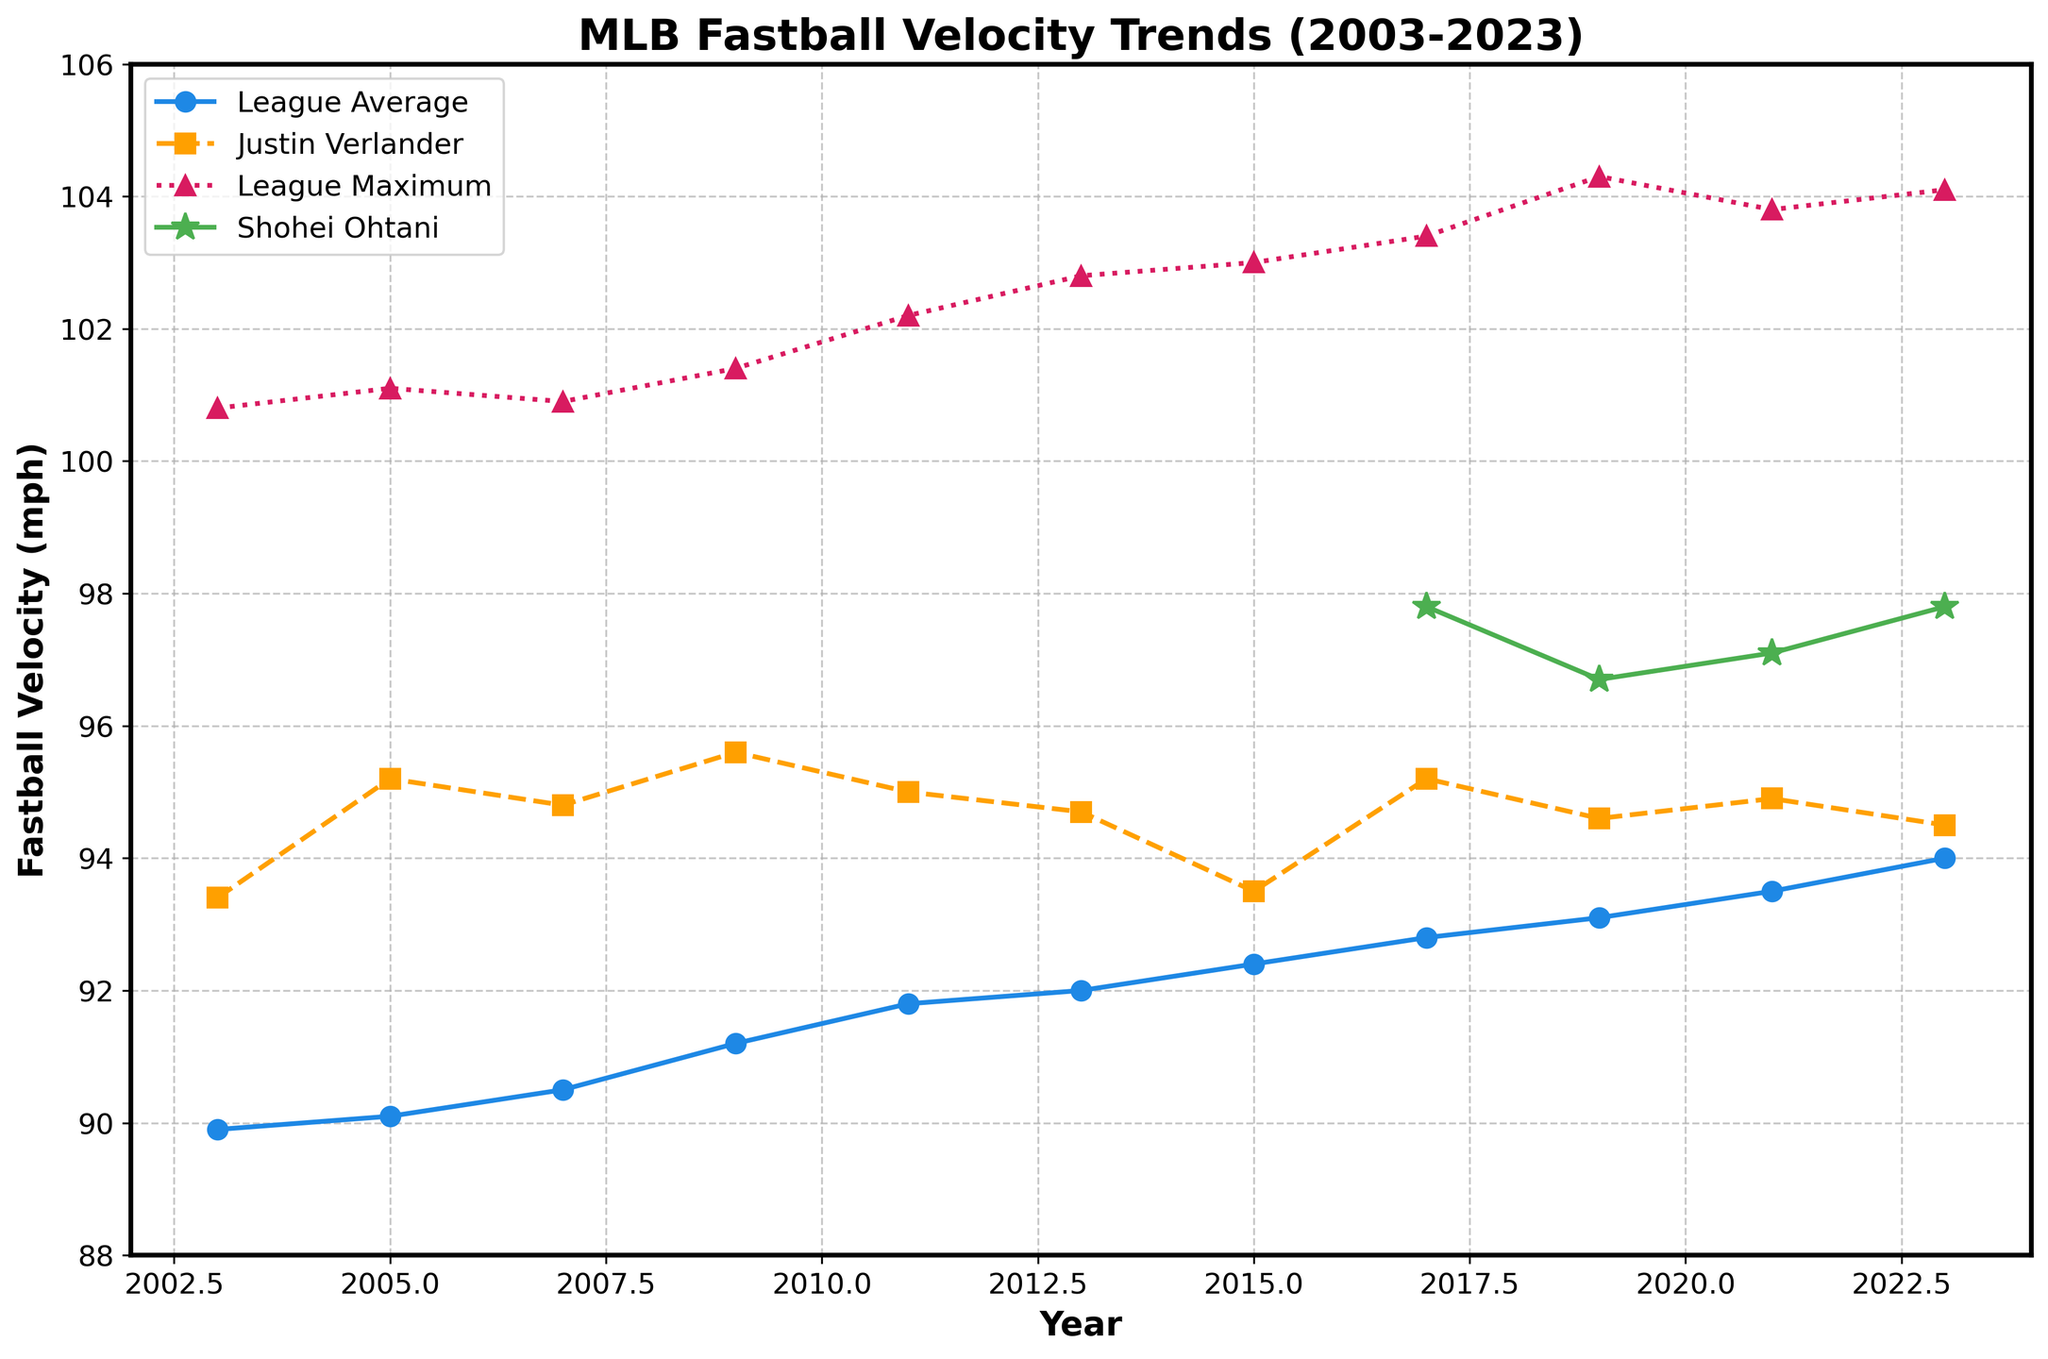What is the trend of the average fastball velocity in MLB from 2003 to 2023? The average fastball velocity has been increasing over time. By looking at the blue line, we can see that the average fastball velocity started at 89.9 mph in 2003 and gradually increased to 94.0 mph in 2023.
Answer: Increasing How does Shohei Ohtani's fastball velocity compare to the league average in 2023? In 2023, Shohei Ohtani's fastball velocity (green line) is 97.8 mph, while the league average fastball velocity (blue line) in the same year is 94.0 mph. Ohtani's velocity is higher than the league average.
Answer: Higher What year did the league average fastball velocity surpass 92 mph? The league average fastball velocity surpassed 92 mph in 2013. This is seen by observing the blue line, where the value in 2013 is 92.0 mph.
Answer: 2013 By how much did Justin Verlander's fastball velocity change from 2009 to 2023? Justin Verlander's fastball velocity was 95.6 mph in 2009 (orange square) and 94.5 mph in 2023 (orange square). The change is 95.6 - 94.5 = 1.1 mph (decrease).
Answer: Decreased by 1.1 mph Which year had the highest league maximum fastball velocity, and what was the value? The year with the highest league maximum fastball velocity is 2019, where the red triangle reaches its peak value of 104.3 mph.
Answer: 2019, 104.3 mph Compare the trends of fastball velocities between Shohei Ohtani and the league average from 2017 to 2023. Shohei Ohtani's fastball velocity (green line) fluctuates slightly but remains consistently higher than the league average (blue line) from 2017 to 2023. Ohtani's velocity also shows two peaks at 97.8 mph in 2017 and 2023. Meanwhile, the league average steadily increases.
Answer: Ohtani's higher, average increases steadily What is the difference between the league maximum and the average fastball velocity in 2023? In 2023, the league maximum fastball velocity (red triangle) is 104.1 mph, and the league average fastball velocity (blue line) is 94.0 mph. The difference is 104.1 - 94.0 = 10.1 mph.
Answer: 10.1 mph Which pitcher has the most consistently high fastball velocity throughout the years covered in the figure? Shohei Ohtani has the most consistently high fastball velocity, remaining around 96.7 mph to 97.8 mph from 2017 to 2023 (green line).
Answer: Shohei Ohtani In which year did Justin Verlander have his peak fastball velocity, and what value was it? Justin Verlander's peak fastball velocity is in 2005, with a value of 95.2 mph (orange square).
Answer: 2005, 95.2 mph 